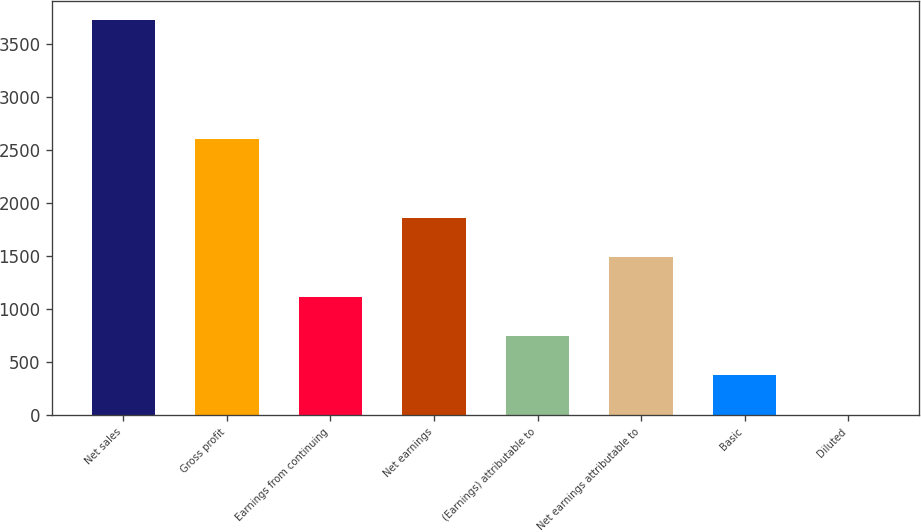Convert chart to OTSL. <chart><loc_0><loc_0><loc_500><loc_500><bar_chart><fcel>Net sales<fcel>Gross profit<fcel>Earnings from continuing<fcel>Net earnings<fcel>(Earnings) attributable to<fcel>Net earnings attributable to<fcel>Basic<fcel>Diluted<nl><fcel>3720.8<fcel>2605.05<fcel>1117.41<fcel>1861.23<fcel>745.5<fcel>1489.32<fcel>373.59<fcel>1.68<nl></chart> 